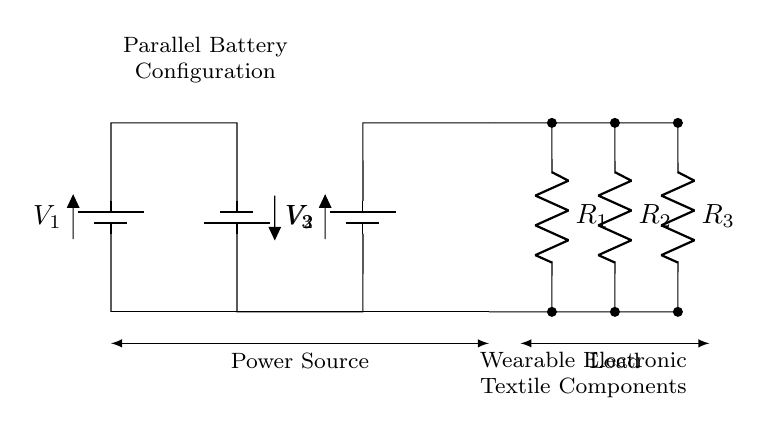What is the total number of batteries in the configuration? The circuit diagram shows three battery components labeled as V1, V2, and V3 connected in parallel. Counting these gives a total of three batteries.
Answer: Three What are the labeled resistances in this circuit? The circuit diagram includes three resistances labeled R1, R2, and R3. These are connected in parallel as load components that consume power from the batteries.
Answer: R1, R2, R3 What type of battery connection is depicted? The circuit shows a parallel configuration as all three batteries are connected along the same voltage rails, sharing the same positive and negative connections.
Answer: Parallel What is the role of resistors in this configuration? Resistors in this circuit act as load elements. They convert electrical energy from the batteries into another form of energy, such as heat, which is essential for wearable electronics that may utilize resistive heating or other functionalities.
Answer: Load elements If battery voltage is V, what is the total voltage across the resistors? In a parallel circuit, the voltage across each battery and the load is the same. Therefore, if the voltage of each battery is V, the total voltage across the resistors remains V.
Answer: V How would increasing the number of batteries affect the circuit? Adding more batteries in parallel would not increase the overall voltage but would increase the available current capacity. This is because the total current output can be the sum of all battery currents while maintaining the same voltage level across the circuit.
Answer: Increase current capacity 